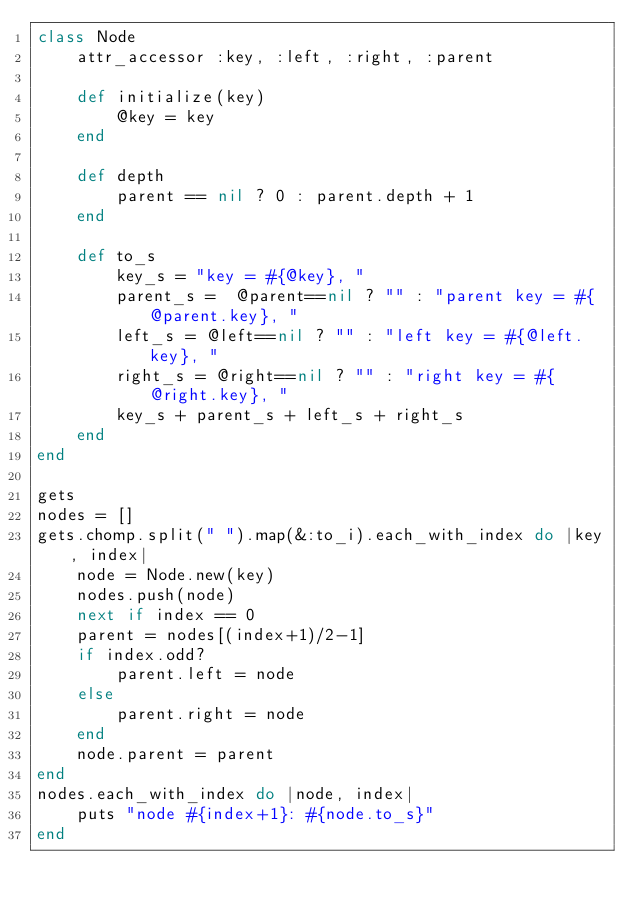Convert code to text. <code><loc_0><loc_0><loc_500><loc_500><_Ruby_>class Node
    attr_accessor :key, :left, :right, :parent

    def initialize(key)
        @key = key
    end

    def depth
        parent == nil ? 0 : parent.depth + 1
    end

    def to_s
        key_s = "key = #{@key}, "
        parent_s =  @parent==nil ? "" : "parent key = #{@parent.key}, "
        left_s = @left==nil ? "" : "left key = #{@left.key}, "
        right_s = @right==nil ? "" : "right key = #{@right.key}, "
        key_s + parent_s + left_s + right_s
    end
end

gets
nodes = []
gets.chomp.split(" ").map(&:to_i).each_with_index do |key, index|
    node = Node.new(key)
    nodes.push(node)
    next if index == 0
    parent = nodes[(index+1)/2-1]
    if index.odd?
        parent.left = node
    else
        parent.right = node
    end
    node.parent = parent
end
nodes.each_with_index do |node, index|
    puts "node #{index+1}: #{node.to_s}"
end

</code> 